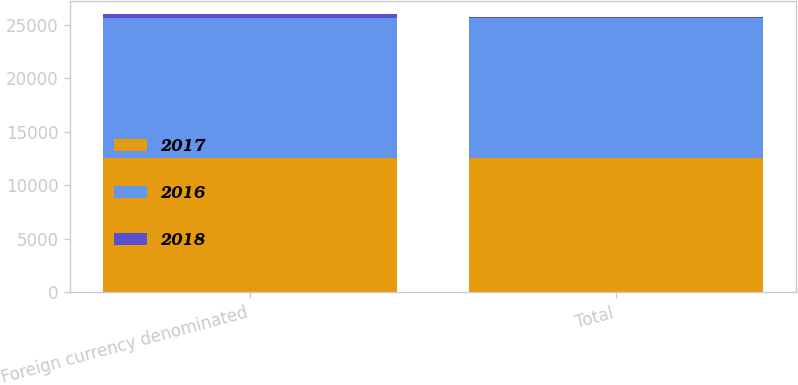Convert chart to OTSL. <chart><loc_0><loc_0><loc_500><loc_500><stacked_bar_chart><ecel><fcel>Foreign currency denominated<fcel>Total<nl><fcel>2017<fcel>12494<fcel>12494<nl><fcel>2016<fcel>13147<fcel>13147<nl><fcel>2018<fcel>304<fcel>67<nl></chart> 